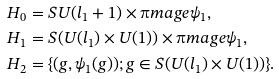<formula> <loc_0><loc_0><loc_500><loc_500>H _ { 0 } & = S U ( l _ { 1 } + 1 ) \times \i m a g e \psi _ { 1 } , \\ H _ { 1 } & = S ( U ( l _ { 1 } ) \times U ( 1 ) ) \times \i m a g e \psi _ { 1 } , \\ H _ { 2 } & = \{ ( g , \psi _ { 1 } ( g ) ) ; g \in S ( U ( l _ { 1 } ) \times U ( 1 ) ) \} .</formula> 